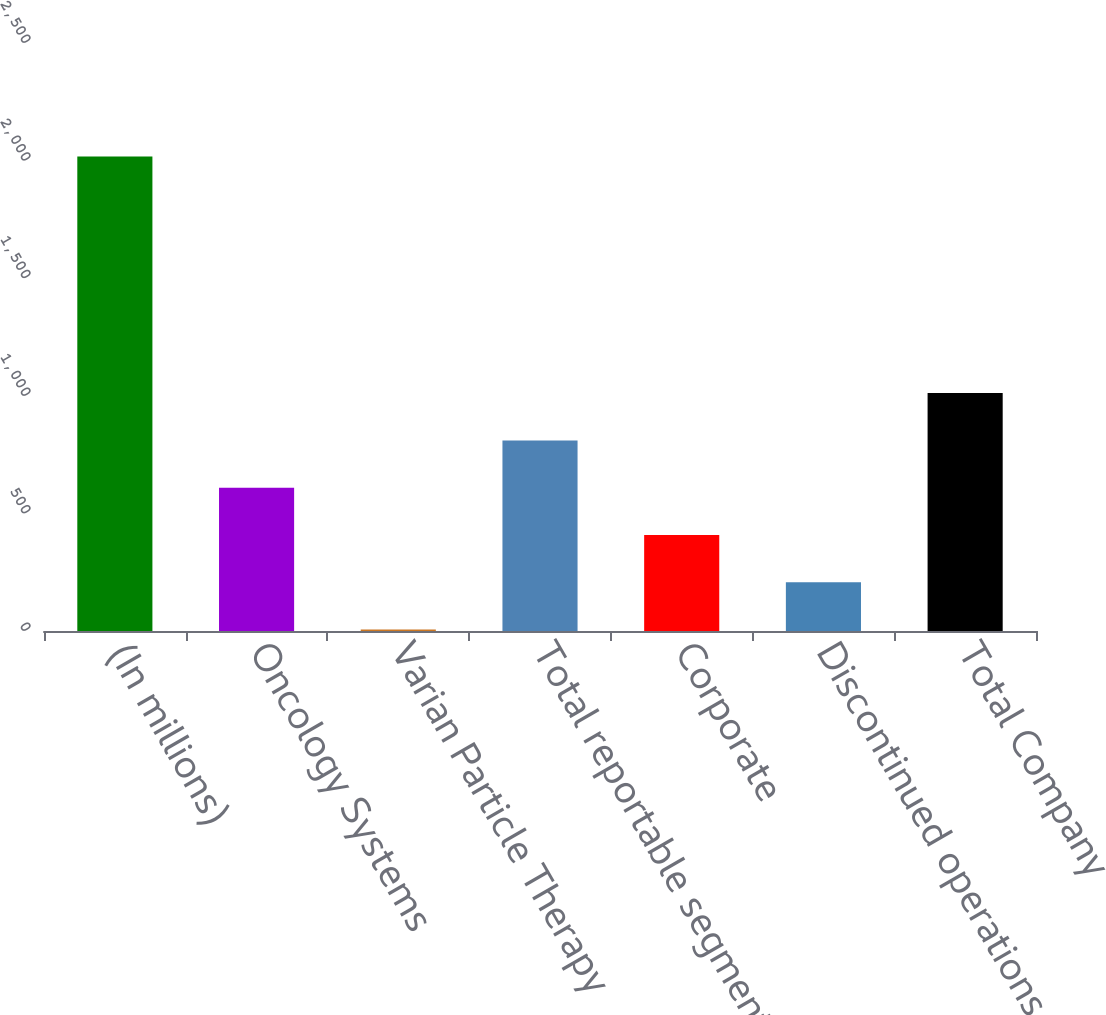<chart> <loc_0><loc_0><loc_500><loc_500><bar_chart><fcel>(In millions)<fcel>Oncology Systems<fcel>Varian Particle Therapy<fcel>Total reportable segments<fcel>Corporate<fcel>Discontinued operations<fcel>Total Company<nl><fcel>2017<fcel>609.37<fcel>6.1<fcel>810.46<fcel>408.28<fcel>207.19<fcel>1011.55<nl></chart> 